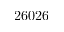Convert formula to latex. <formula><loc_0><loc_0><loc_500><loc_500>2 6 0 2 6</formula> 